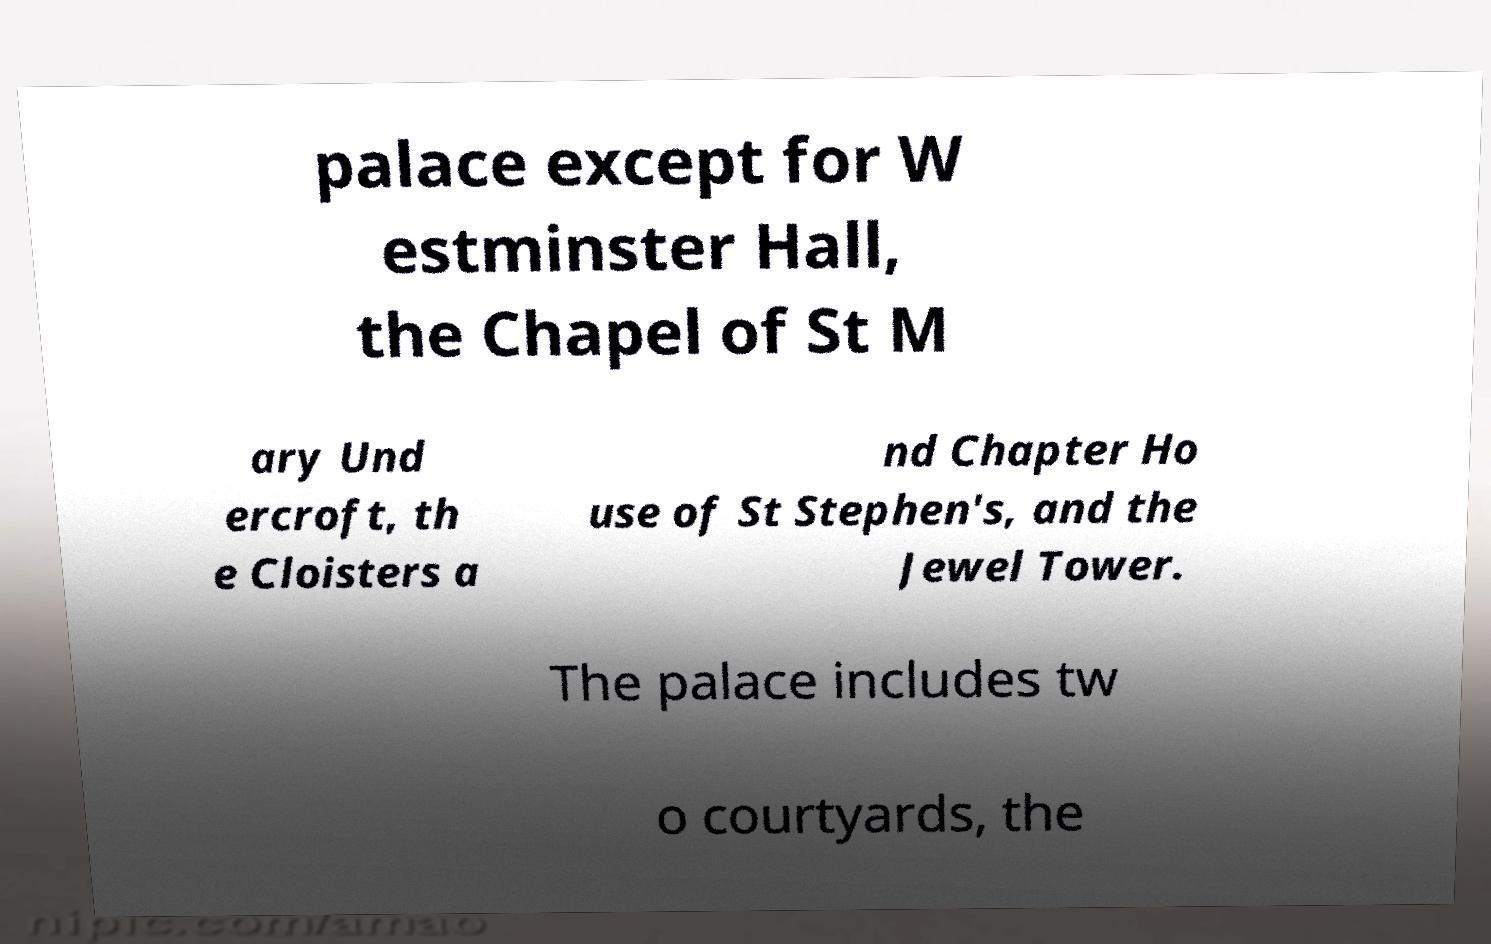Can you accurately transcribe the text from the provided image for me? palace except for W estminster Hall, the Chapel of St M ary Und ercroft, th e Cloisters a nd Chapter Ho use of St Stephen's, and the Jewel Tower. The palace includes tw o courtyards, the 